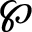Convert formula to latex. <formula><loc_0><loc_0><loc_500><loc_500>\wp</formula> 